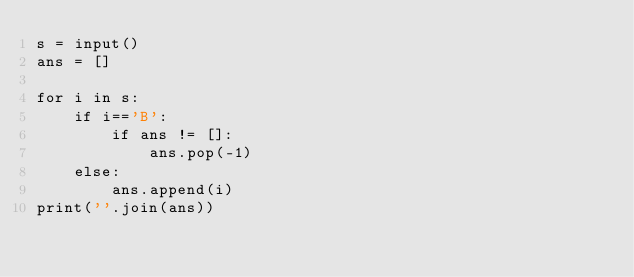Convert code to text. <code><loc_0><loc_0><loc_500><loc_500><_Python_>s = input()
ans = []

for i in s:
    if i=='B':
        if ans != []:
            ans.pop(-1)
    else:
        ans.append(i)
print(''.join(ans))</code> 